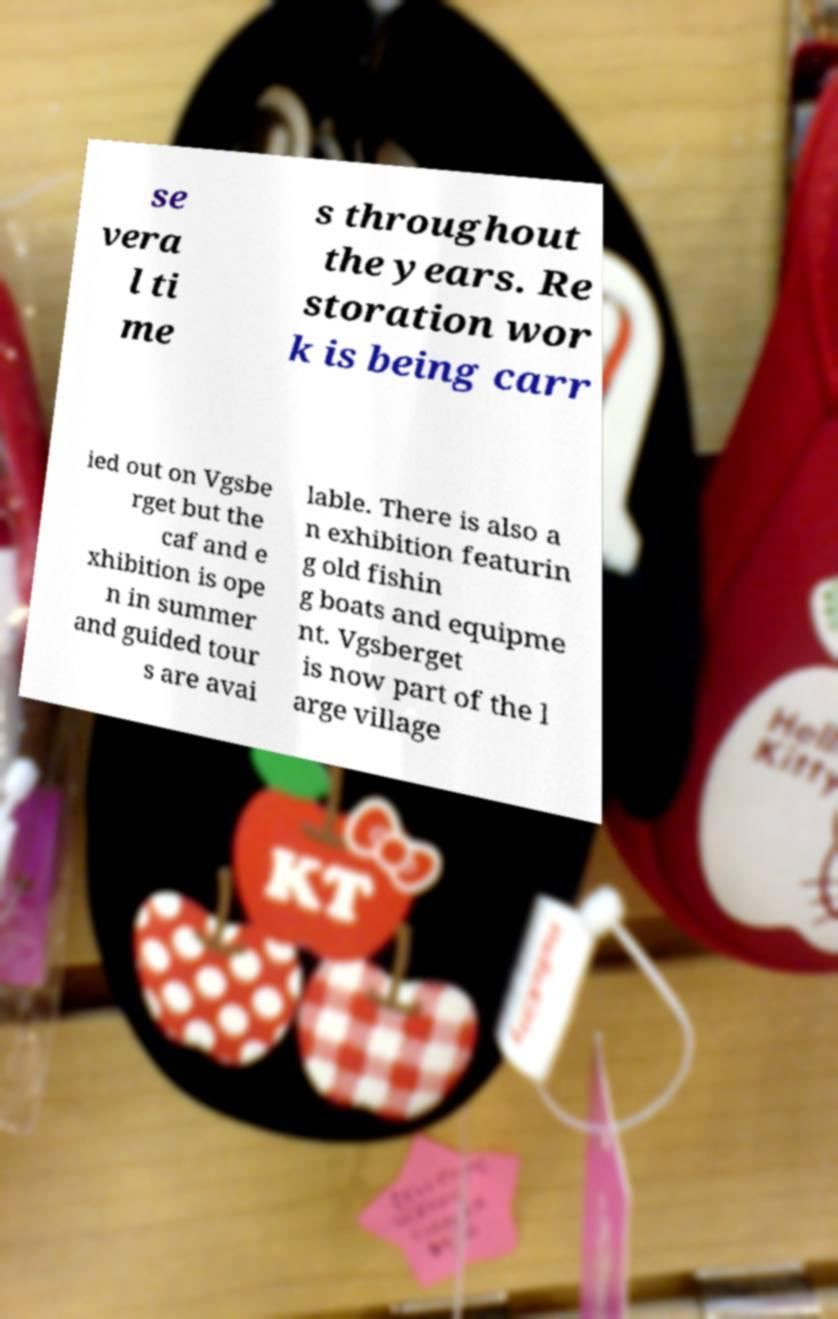What messages or text are displayed in this image? I need them in a readable, typed format. se vera l ti me s throughout the years. Re storation wor k is being carr ied out on Vgsbe rget but the caf and e xhibition is ope n in summer and guided tour s are avai lable. There is also a n exhibition featurin g old fishin g boats and equipme nt. Vgsberget is now part of the l arge village 